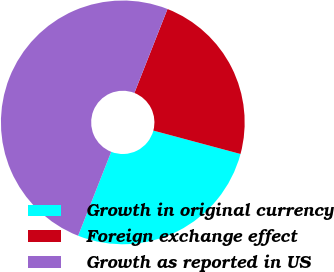Convert chart to OTSL. <chart><loc_0><loc_0><loc_500><loc_500><pie_chart><fcel>Growth in original currency<fcel>Foreign exchange effect<fcel>Growth as reported in US<nl><fcel>26.8%<fcel>23.2%<fcel>50.0%<nl></chart> 